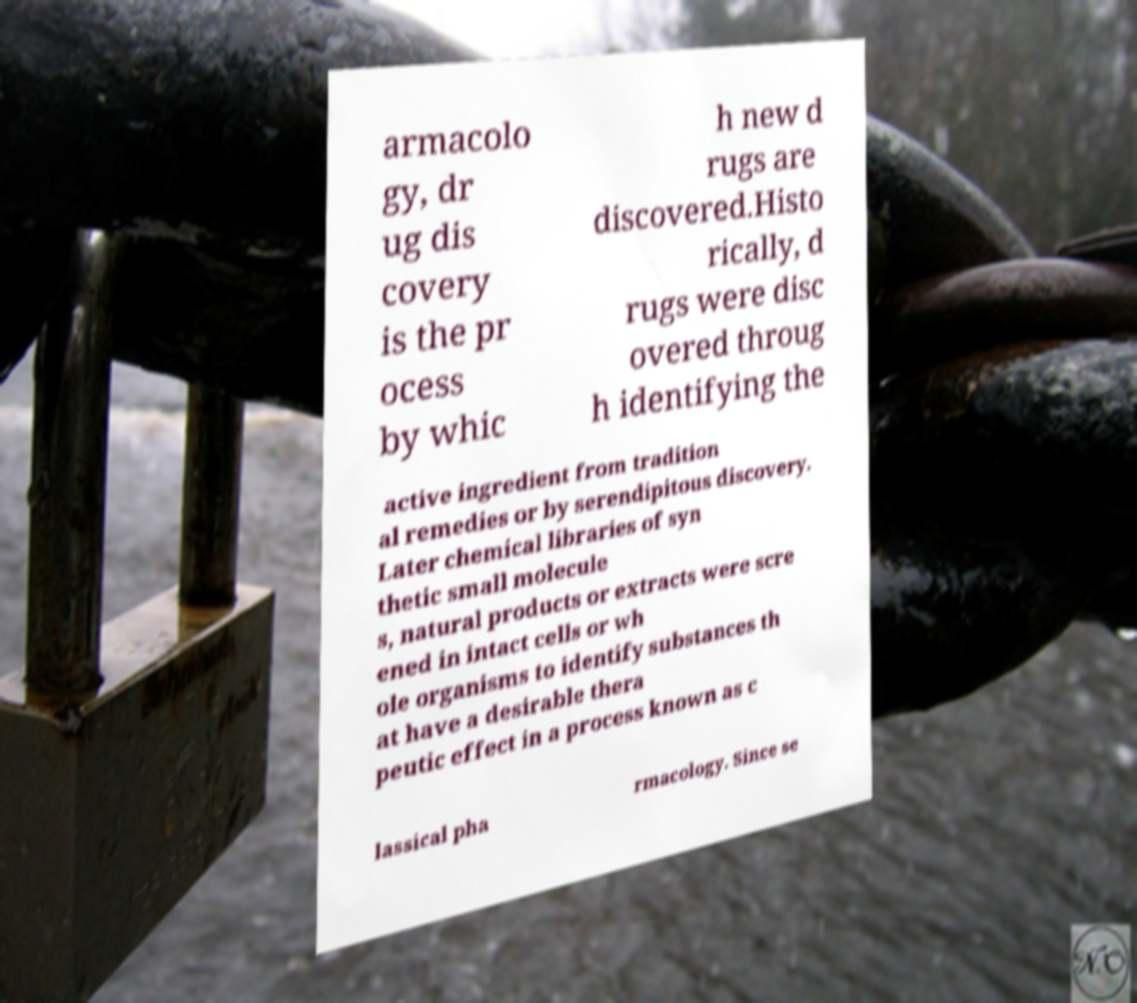Can you read and provide the text displayed in the image?This photo seems to have some interesting text. Can you extract and type it out for me? armacolo gy, dr ug dis covery is the pr ocess by whic h new d rugs are discovered.Histo rically, d rugs were disc overed throug h identifying the active ingredient from tradition al remedies or by serendipitous discovery. Later chemical libraries of syn thetic small molecule s, natural products or extracts were scre ened in intact cells or wh ole organisms to identify substances th at have a desirable thera peutic effect in a process known as c lassical pha rmacology. Since se 